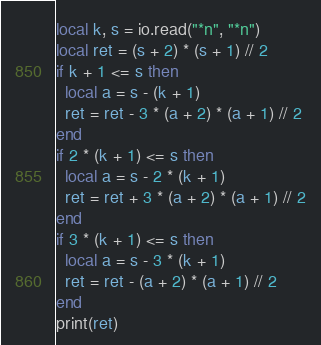Convert code to text. <code><loc_0><loc_0><loc_500><loc_500><_Lua_>local k, s = io.read("*n", "*n")
local ret = (s + 2) * (s + 1) // 2
if k + 1 <= s then
  local a = s - (k + 1)
  ret = ret - 3 * (a + 2) * (a + 1) // 2
end
if 2 * (k + 1) <= s then
  local a = s - 2 * (k + 1)
  ret = ret + 3 * (a + 2) * (a + 1) // 2
end
if 3 * (k + 1) <= s then
  local a = s - 3 * (k + 1)
  ret = ret - (a + 2) * (a + 1) // 2
end
print(ret)
</code> 